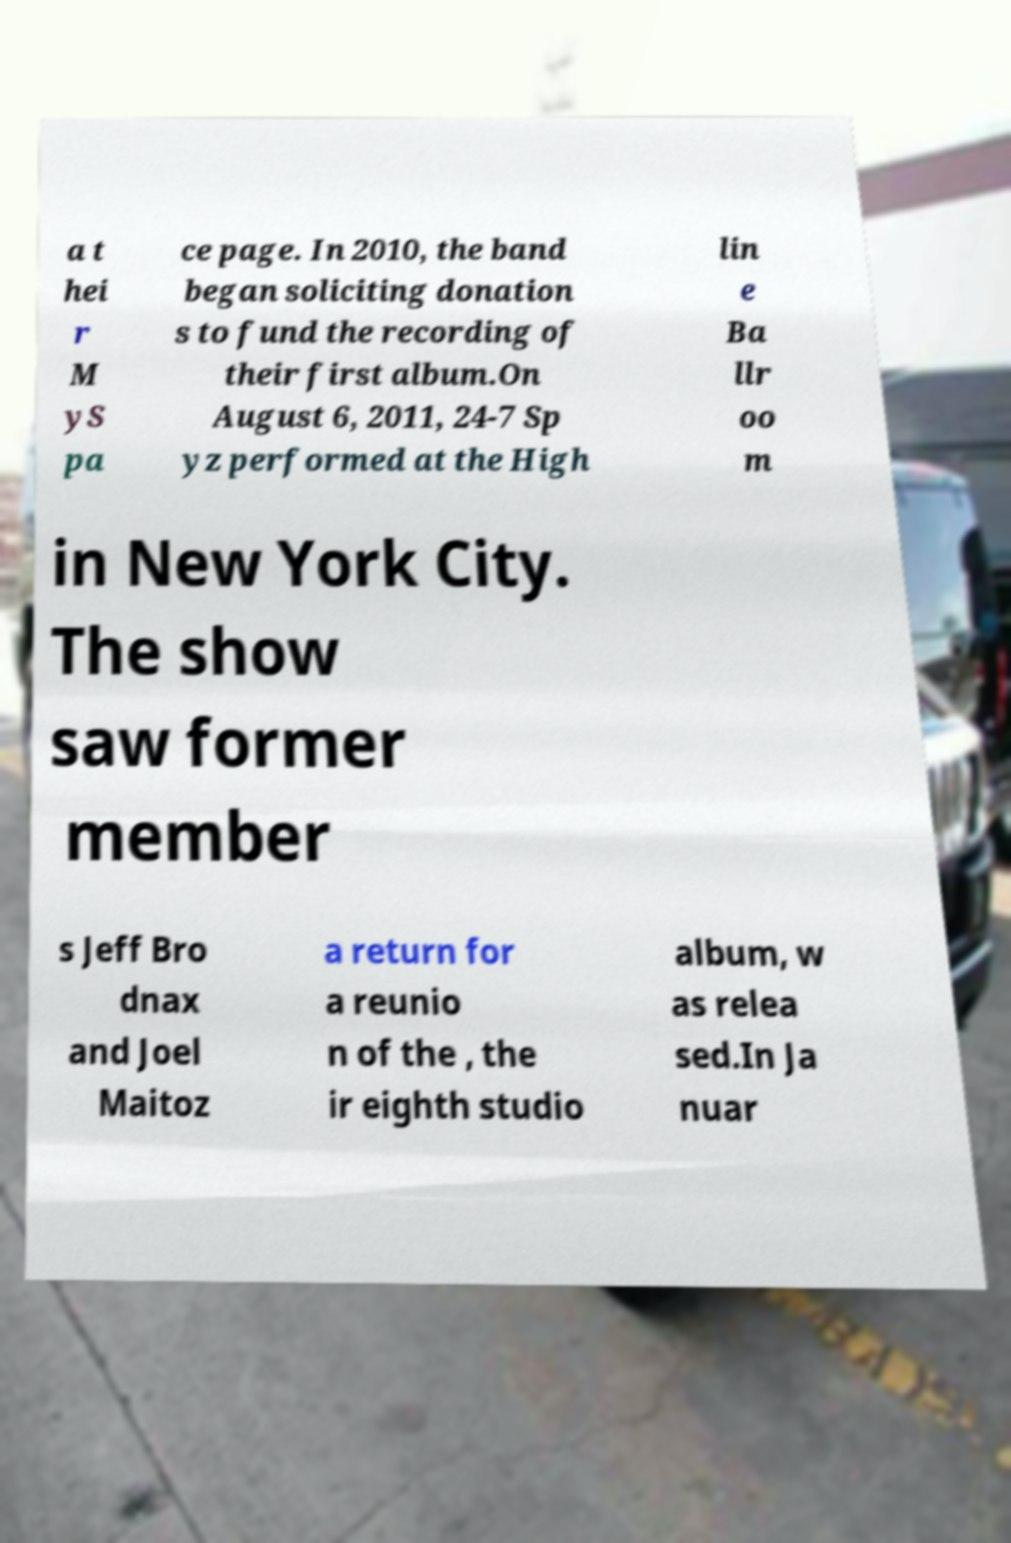There's text embedded in this image that I need extracted. Can you transcribe it verbatim? a t hei r M yS pa ce page. In 2010, the band began soliciting donation s to fund the recording of their first album.On August 6, 2011, 24-7 Sp yz performed at the High lin e Ba llr oo m in New York City. The show saw former member s Jeff Bro dnax and Joel Maitoz a return for a reunio n of the , the ir eighth studio album, w as relea sed.In Ja nuar 